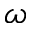Convert formula to latex. <formula><loc_0><loc_0><loc_500><loc_500>\omega</formula> 